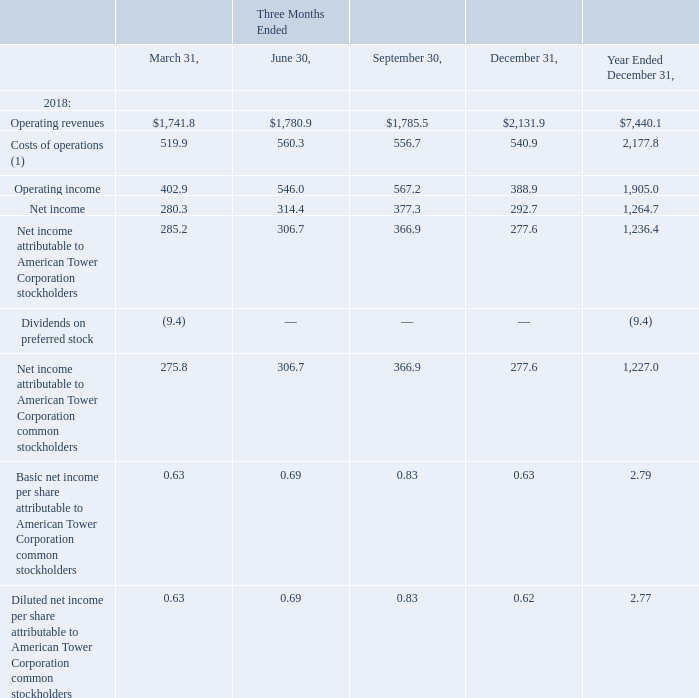AMERICAN TOWER CORPORATION AND SUBSIDIARIES NOTES TO CONSOLIDATED FINANCIAL STATEMENTS (Tabular amounts in millions, unless otherwise disclosed)
23. SELECTED QUARTERLY FINANCIAL DATA (UNAUDITED)
Selected quarterly financial data for the years ended December 31, 2019 and 2018 is as follows (in millions, except per share data):
(1) Represents Operating expenses, exclusive of Depreciation, amortization and accretion, Selling, general, administrative and development expense, and Other operating expenses.
What does the cost of operations represent? Represents operating expenses, exclusive of depreciation, amortization and accretion, selling, general, administrative and development expense, and other operating expenses. What was the net income at the end of March 31?
Answer scale should be: million. 280.3. What was the operating income at the end of June 30?
Answer scale should be: million. 546.0. How many quarters had operating revenues that was below $2,000 million? March##June##September
Answer: 3. What was the change in Operating revenues between Three Months Ended March and June?
Answer scale should be: million. $1,780.9-$1,741.8
Answer: 39.1. What was the percentage change in operating revenues between Three Months Ended  September and December?
Answer scale should be: percent. ($2,131.9-$1,785.5)/$1,785.5
Answer: 19.4. 